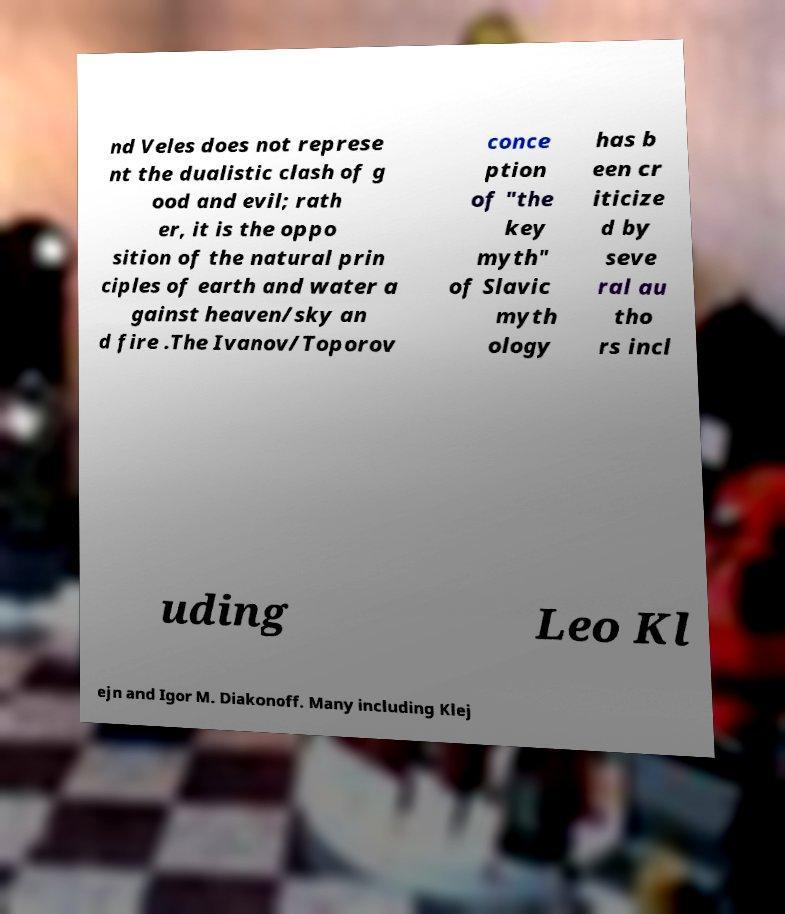Please identify and transcribe the text found in this image. nd Veles does not represe nt the dualistic clash of g ood and evil; rath er, it is the oppo sition of the natural prin ciples of earth and water a gainst heaven/sky an d fire .The Ivanov/Toporov conce ption of "the key myth" of Slavic myth ology has b een cr iticize d by seve ral au tho rs incl uding Leo Kl ejn and Igor M. Diakonoff. Many including Klej 